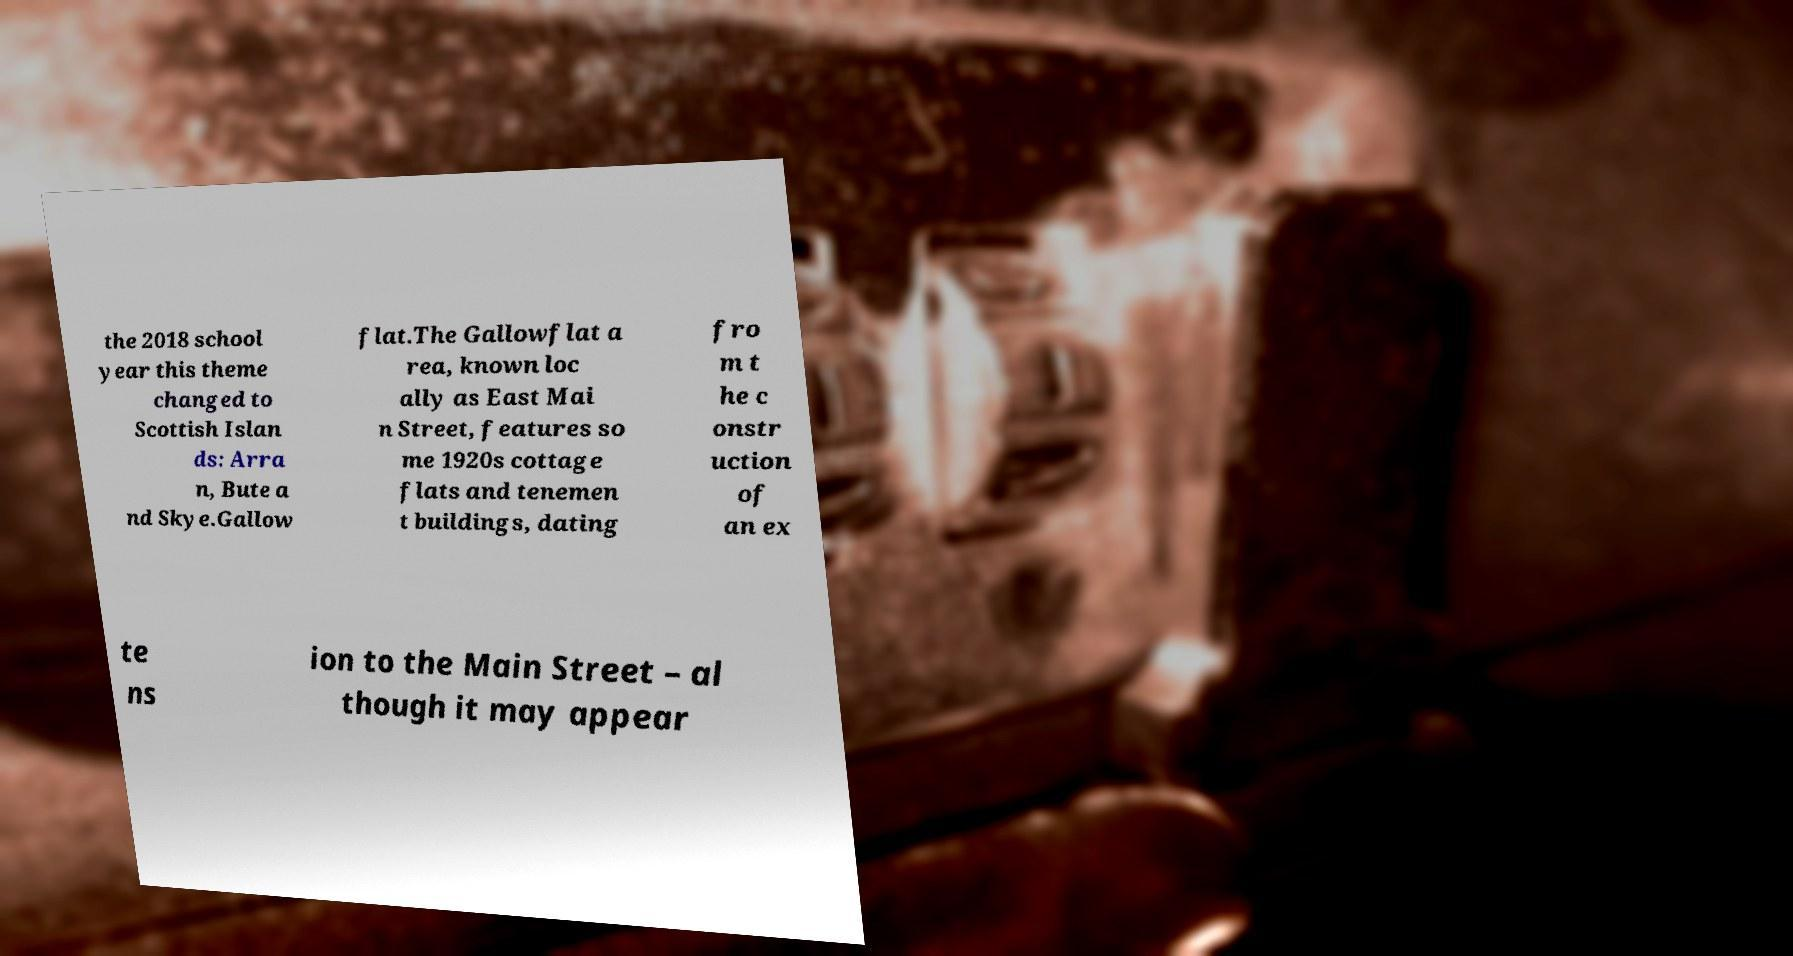Could you assist in decoding the text presented in this image and type it out clearly? the 2018 school year this theme changed to Scottish Islan ds: Arra n, Bute a nd Skye.Gallow flat.The Gallowflat a rea, known loc ally as East Mai n Street, features so me 1920s cottage flats and tenemen t buildings, dating fro m t he c onstr uction of an ex te ns ion to the Main Street – al though it may appear 